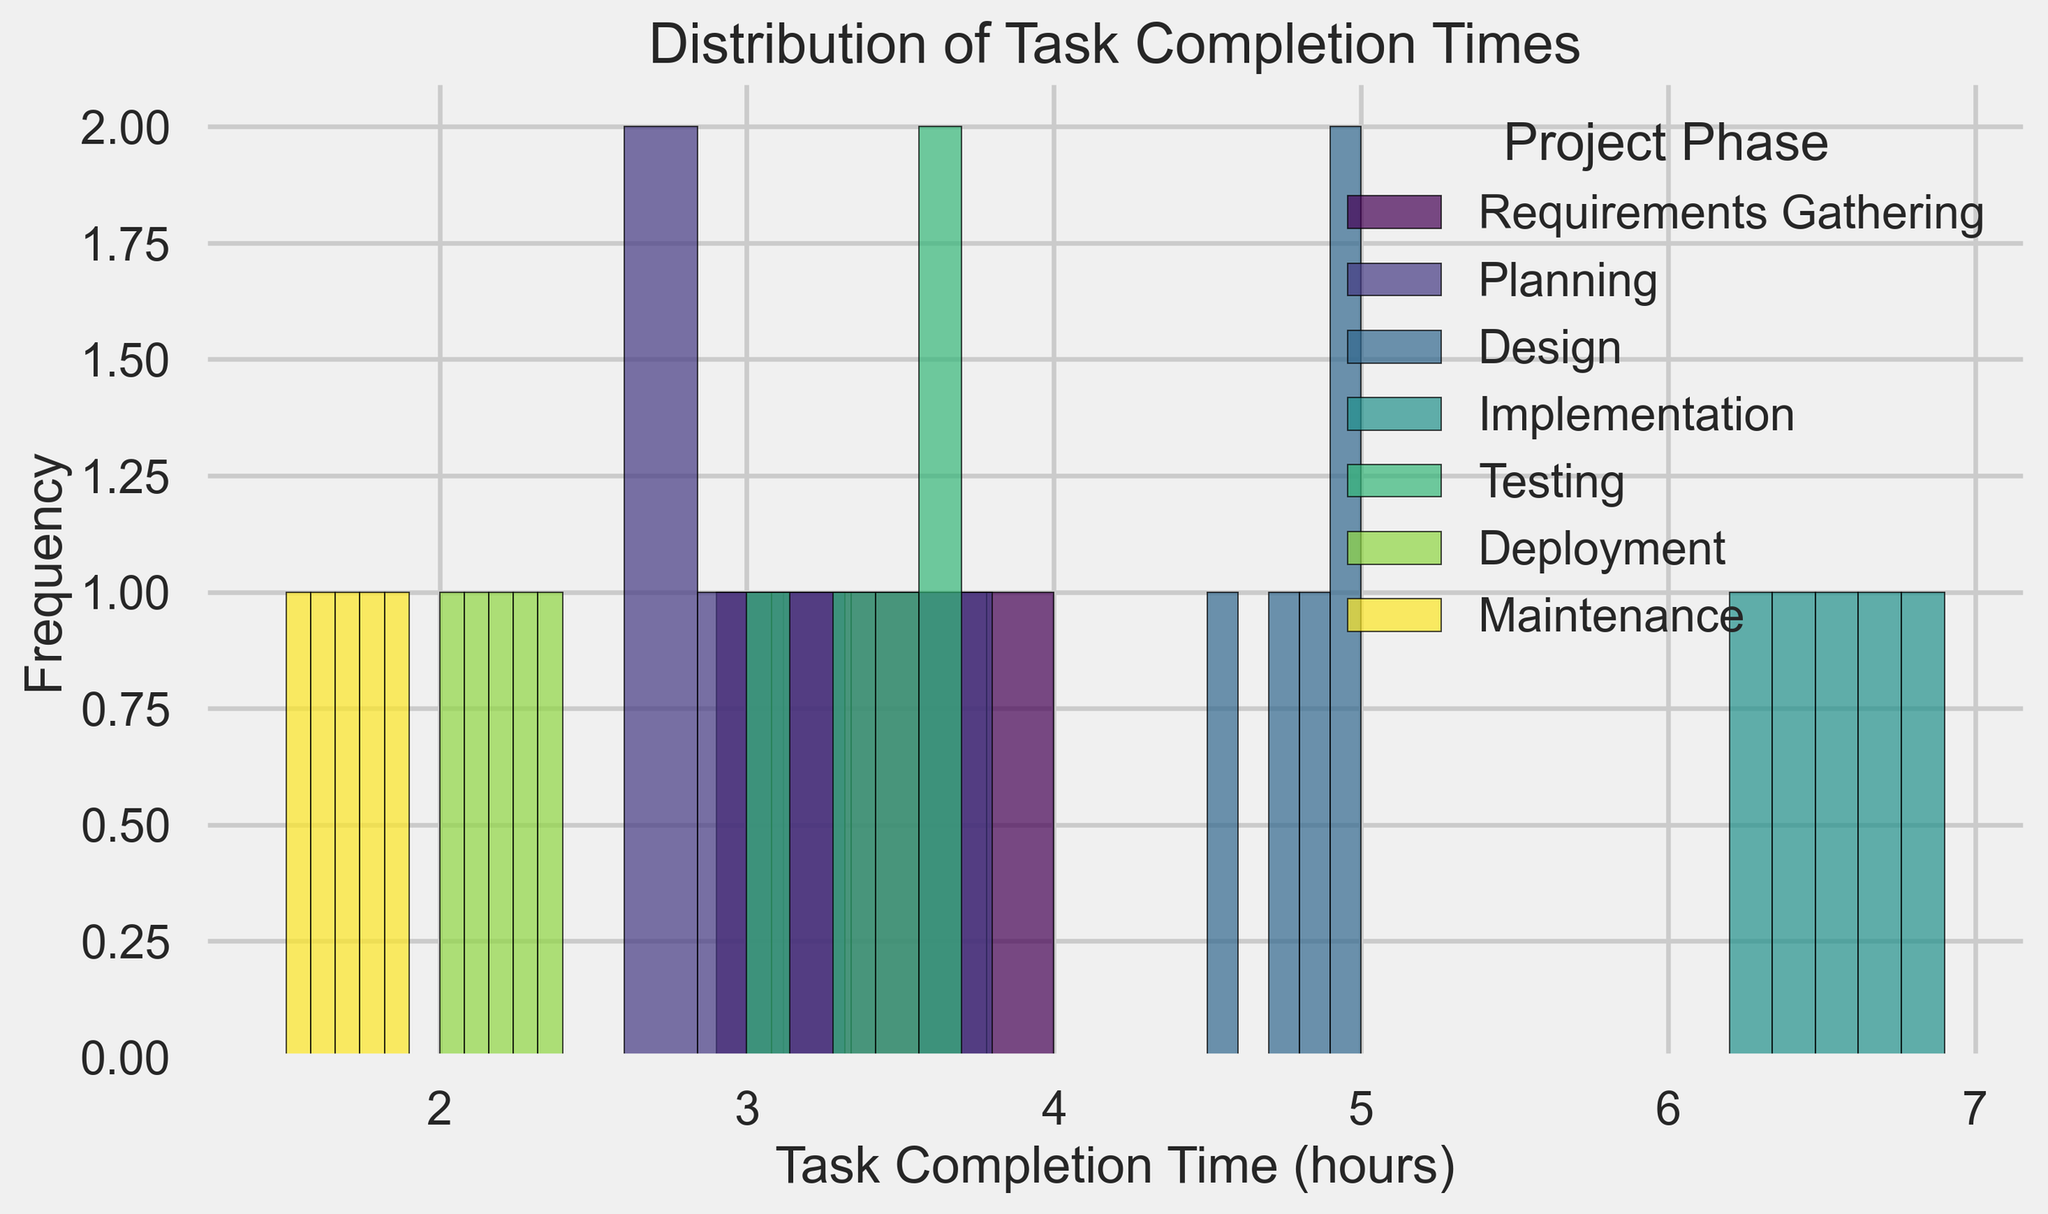What is the phase with the highest task completion time? To determine the phase with the highest task completion time, look for the phase with the rightmost data points. The Implementation phase has the highest task completion times around 6.9 hours.
Answer: Implementation Which phase has the widest spread of task completion times? The spread can be observed by comparing the widths of the histograms for each phase. The Implementation phase has task completion times ranging from 6.2 to 6.9 hours, the widest range in the chart.
Answer: Implementation What is the approximate average task completion time for the Testing phase? First, identify the bars corresponding to the Testing phase. Estimate the midpoint for each bar and average these midpoints, taking into account the frequency.
Answer: Around 3.4 hours Which two phases have the most similar task completion time distributions? Compare the histograms visually. The Requirements Gathering phase and the Testing phase both have similar ranges and distribution shapes, centered around the 3-4 hour mark.
Answer: Requirements Gathering and Testing How does the frequency of task completion times in the Deployment phase compare to the Maintenance phase? Compare the heights of the bars for Deployment and Maintenance. Both have similar heights, but Maintenance has slightly higher frequencies.
Answer: Maintenance is slightly higher What visual attribute differentiates the Implementation phase the most from other phases? The Implementation phase is most differentiated by its histogram being positioned farthest to the right, indicating higher task completion times.
Answer: Higher task completion times Which phase has the lowest task completion times? The lowest task completion times can be identified by locating the leftmost data points. The Maintenance phase has task completion times around 1.5-1.9 hours, the lowest in the chart.
Answer: Maintenance What's the mode of the Requirements Gathering phase? The mode is the value that appears most frequently in each histogram. For the Requirements Gathering phase, 3.7 hours appears to be the most frequent.
Answer: 3.7 hours 